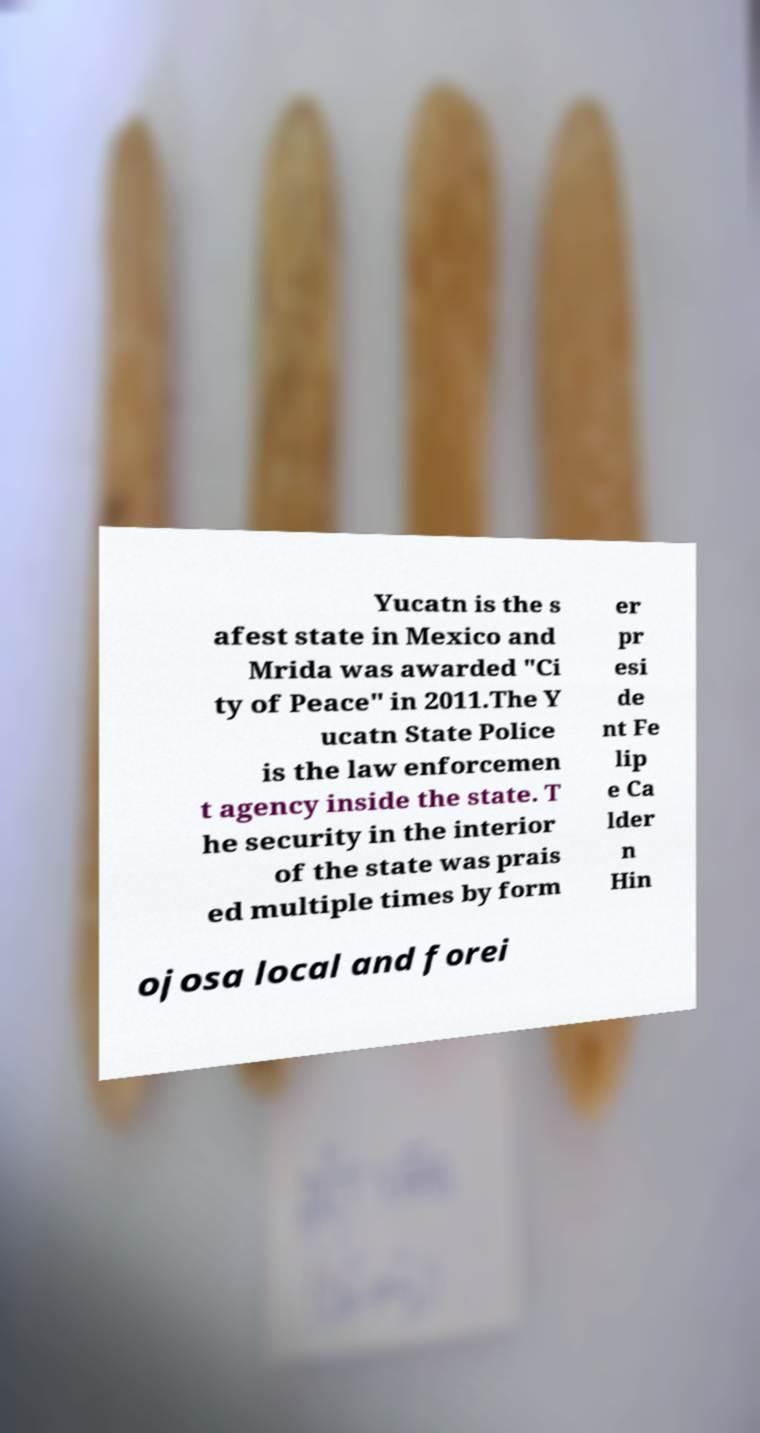I need the written content from this picture converted into text. Can you do that? Yucatn is the s afest state in Mexico and Mrida was awarded "Ci ty of Peace" in 2011.The Y ucatn State Police is the law enforcemen t agency inside the state. T he security in the interior of the state was prais ed multiple times by form er pr esi de nt Fe lip e Ca lder n Hin ojosa local and forei 